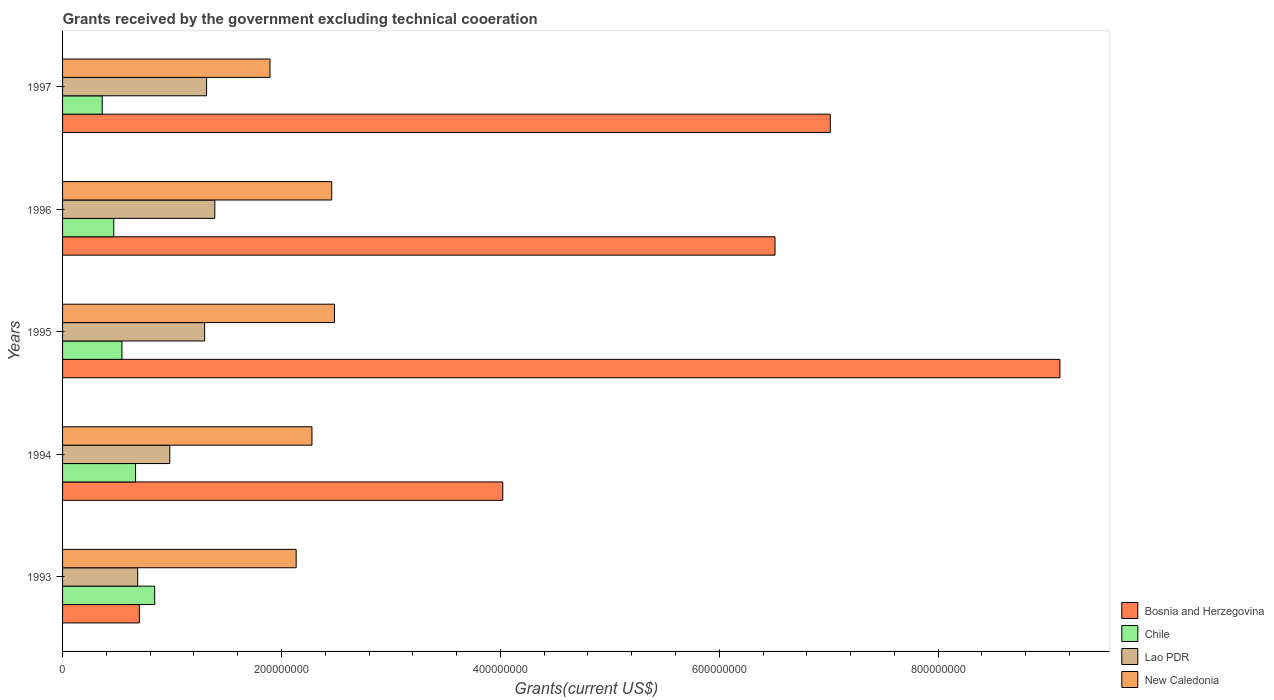How many different coloured bars are there?
Offer a very short reply. 4. Are the number of bars per tick equal to the number of legend labels?
Ensure brevity in your answer.  Yes. Are the number of bars on each tick of the Y-axis equal?
Give a very brief answer. Yes. How many bars are there on the 1st tick from the top?
Give a very brief answer. 4. How many bars are there on the 5th tick from the bottom?
Your answer should be compact. 4. In how many cases, is the number of bars for a given year not equal to the number of legend labels?
Give a very brief answer. 0. What is the total grants received by the government in New Caledonia in 1993?
Provide a short and direct response. 2.13e+08. Across all years, what is the maximum total grants received by the government in Chile?
Your answer should be compact. 8.42e+07. Across all years, what is the minimum total grants received by the government in Bosnia and Herzegovina?
Offer a very short reply. 7.02e+07. In which year was the total grants received by the government in Chile minimum?
Your answer should be compact. 1997. What is the total total grants received by the government in Bosnia and Herzegovina in the graph?
Ensure brevity in your answer.  2.74e+09. What is the difference between the total grants received by the government in Lao PDR in 1995 and that in 1996?
Your response must be concise. -9.30e+06. What is the difference between the total grants received by the government in New Caledonia in 1994 and the total grants received by the government in Chile in 1996?
Your answer should be compact. 1.81e+08. What is the average total grants received by the government in Chile per year?
Give a very brief answer. 5.76e+07. In the year 1996, what is the difference between the total grants received by the government in New Caledonia and total grants received by the government in Bosnia and Herzegovina?
Offer a very short reply. -4.05e+08. What is the ratio of the total grants received by the government in Lao PDR in 1994 to that in 1995?
Offer a terse response. 0.75. Is the total grants received by the government in New Caledonia in 1993 less than that in 1997?
Provide a succinct answer. No. Is the difference between the total grants received by the government in New Caledonia in 1996 and 1997 greater than the difference between the total grants received by the government in Bosnia and Herzegovina in 1996 and 1997?
Give a very brief answer. Yes. What is the difference between the highest and the second highest total grants received by the government in New Caledonia?
Make the answer very short. 2.51e+06. What is the difference between the highest and the lowest total grants received by the government in Chile?
Your response must be concise. 4.79e+07. In how many years, is the total grants received by the government in Lao PDR greater than the average total grants received by the government in Lao PDR taken over all years?
Offer a terse response. 3. Is it the case that in every year, the sum of the total grants received by the government in Lao PDR and total grants received by the government in New Caledonia is greater than the sum of total grants received by the government in Chile and total grants received by the government in Bosnia and Herzegovina?
Ensure brevity in your answer.  No. What does the 1st bar from the top in 1994 represents?
Offer a very short reply. New Caledonia. What does the 3rd bar from the bottom in 1994 represents?
Provide a succinct answer. Lao PDR. How many years are there in the graph?
Provide a short and direct response. 5. What is the difference between two consecutive major ticks on the X-axis?
Ensure brevity in your answer.  2.00e+08. Does the graph contain any zero values?
Provide a succinct answer. No. Where does the legend appear in the graph?
Ensure brevity in your answer.  Bottom right. How many legend labels are there?
Provide a short and direct response. 4. What is the title of the graph?
Keep it short and to the point. Grants received by the government excluding technical cooeration. Does "Cuba" appear as one of the legend labels in the graph?
Give a very brief answer. No. What is the label or title of the X-axis?
Provide a succinct answer. Grants(current US$). What is the Grants(current US$) of Bosnia and Herzegovina in 1993?
Offer a very short reply. 7.02e+07. What is the Grants(current US$) in Chile in 1993?
Ensure brevity in your answer.  8.42e+07. What is the Grants(current US$) in Lao PDR in 1993?
Your answer should be very brief. 6.86e+07. What is the Grants(current US$) in New Caledonia in 1993?
Keep it short and to the point. 2.13e+08. What is the Grants(current US$) in Bosnia and Herzegovina in 1994?
Offer a terse response. 4.02e+08. What is the Grants(current US$) in Chile in 1994?
Provide a short and direct response. 6.67e+07. What is the Grants(current US$) of Lao PDR in 1994?
Your response must be concise. 9.80e+07. What is the Grants(current US$) in New Caledonia in 1994?
Offer a terse response. 2.28e+08. What is the Grants(current US$) of Bosnia and Herzegovina in 1995?
Offer a terse response. 9.11e+08. What is the Grants(current US$) of Chile in 1995?
Your response must be concise. 5.42e+07. What is the Grants(current US$) of Lao PDR in 1995?
Give a very brief answer. 1.30e+08. What is the Grants(current US$) in New Caledonia in 1995?
Your response must be concise. 2.48e+08. What is the Grants(current US$) in Bosnia and Herzegovina in 1996?
Give a very brief answer. 6.51e+08. What is the Grants(current US$) in Chile in 1996?
Provide a succinct answer. 4.68e+07. What is the Grants(current US$) in Lao PDR in 1996?
Offer a terse response. 1.39e+08. What is the Grants(current US$) in New Caledonia in 1996?
Your response must be concise. 2.46e+08. What is the Grants(current US$) in Bosnia and Herzegovina in 1997?
Provide a succinct answer. 7.01e+08. What is the Grants(current US$) in Chile in 1997?
Your response must be concise. 3.62e+07. What is the Grants(current US$) in Lao PDR in 1997?
Ensure brevity in your answer.  1.32e+08. What is the Grants(current US$) in New Caledonia in 1997?
Offer a very short reply. 1.90e+08. Across all years, what is the maximum Grants(current US$) in Bosnia and Herzegovina?
Keep it short and to the point. 9.11e+08. Across all years, what is the maximum Grants(current US$) of Chile?
Give a very brief answer. 8.42e+07. Across all years, what is the maximum Grants(current US$) in Lao PDR?
Offer a terse response. 1.39e+08. Across all years, what is the maximum Grants(current US$) of New Caledonia?
Offer a terse response. 2.48e+08. Across all years, what is the minimum Grants(current US$) in Bosnia and Herzegovina?
Provide a short and direct response. 7.02e+07. Across all years, what is the minimum Grants(current US$) in Chile?
Provide a short and direct response. 3.62e+07. Across all years, what is the minimum Grants(current US$) in Lao PDR?
Offer a terse response. 6.86e+07. Across all years, what is the minimum Grants(current US$) in New Caledonia?
Your response must be concise. 1.90e+08. What is the total Grants(current US$) in Bosnia and Herzegovina in the graph?
Keep it short and to the point. 2.74e+09. What is the total Grants(current US$) of Chile in the graph?
Your answer should be compact. 2.88e+08. What is the total Grants(current US$) of Lao PDR in the graph?
Keep it short and to the point. 5.67e+08. What is the total Grants(current US$) in New Caledonia in the graph?
Give a very brief answer. 1.13e+09. What is the difference between the Grants(current US$) in Bosnia and Herzegovina in 1993 and that in 1994?
Ensure brevity in your answer.  -3.32e+08. What is the difference between the Grants(current US$) of Chile in 1993 and that in 1994?
Your response must be concise. 1.75e+07. What is the difference between the Grants(current US$) in Lao PDR in 1993 and that in 1994?
Provide a short and direct response. -2.93e+07. What is the difference between the Grants(current US$) of New Caledonia in 1993 and that in 1994?
Provide a succinct answer. -1.44e+07. What is the difference between the Grants(current US$) in Bosnia and Herzegovina in 1993 and that in 1995?
Provide a succinct answer. -8.41e+08. What is the difference between the Grants(current US$) in Chile in 1993 and that in 1995?
Your response must be concise. 2.99e+07. What is the difference between the Grants(current US$) of Lao PDR in 1993 and that in 1995?
Ensure brevity in your answer.  -6.12e+07. What is the difference between the Grants(current US$) in New Caledonia in 1993 and that in 1995?
Keep it short and to the point. -3.50e+07. What is the difference between the Grants(current US$) in Bosnia and Herzegovina in 1993 and that in 1996?
Make the answer very short. -5.81e+08. What is the difference between the Grants(current US$) of Chile in 1993 and that in 1996?
Keep it short and to the point. 3.74e+07. What is the difference between the Grants(current US$) in Lao PDR in 1993 and that in 1996?
Make the answer very short. -7.05e+07. What is the difference between the Grants(current US$) of New Caledonia in 1993 and that in 1996?
Provide a short and direct response. -3.25e+07. What is the difference between the Grants(current US$) of Bosnia and Herzegovina in 1993 and that in 1997?
Your answer should be compact. -6.31e+08. What is the difference between the Grants(current US$) of Chile in 1993 and that in 1997?
Provide a succinct answer. 4.79e+07. What is the difference between the Grants(current US$) of Lao PDR in 1993 and that in 1997?
Your response must be concise. -6.29e+07. What is the difference between the Grants(current US$) in New Caledonia in 1993 and that in 1997?
Offer a very short reply. 2.39e+07. What is the difference between the Grants(current US$) of Bosnia and Herzegovina in 1994 and that in 1995?
Your answer should be compact. -5.09e+08. What is the difference between the Grants(current US$) of Chile in 1994 and that in 1995?
Give a very brief answer. 1.24e+07. What is the difference between the Grants(current US$) in Lao PDR in 1994 and that in 1995?
Offer a terse response. -3.18e+07. What is the difference between the Grants(current US$) of New Caledonia in 1994 and that in 1995?
Provide a short and direct response. -2.06e+07. What is the difference between the Grants(current US$) in Bosnia and Herzegovina in 1994 and that in 1996?
Your answer should be compact. -2.49e+08. What is the difference between the Grants(current US$) in Chile in 1994 and that in 1996?
Ensure brevity in your answer.  1.99e+07. What is the difference between the Grants(current US$) in Lao PDR in 1994 and that in 1996?
Provide a succinct answer. -4.11e+07. What is the difference between the Grants(current US$) of New Caledonia in 1994 and that in 1996?
Make the answer very short. -1.80e+07. What is the difference between the Grants(current US$) in Bosnia and Herzegovina in 1994 and that in 1997?
Offer a very short reply. -2.99e+08. What is the difference between the Grants(current US$) in Chile in 1994 and that in 1997?
Provide a short and direct response. 3.04e+07. What is the difference between the Grants(current US$) of Lao PDR in 1994 and that in 1997?
Offer a very short reply. -3.36e+07. What is the difference between the Grants(current US$) in New Caledonia in 1994 and that in 1997?
Provide a short and direct response. 3.83e+07. What is the difference between the Grants(current US$) of Bosnia and Herzegovina in 1995 and that in 1996?
Keep it short and to the point. 2.60e+08. What is the difference between the Grants(current US$) in Chile in 1995 and that in 1996?
Provide a short and direct response. 7.46e+06. What is the difference between the Grants(current US$) of Lao PDR in 1995 and that in 1996?
Provide a short and direct response. -9.30e+06. What is the difference between the Grants(current US$) of New Caledonia in 1995 and that in 1996?
Your response must be concise. 2.51e+06. What is the difference between the Grants(current US$) in Bosnia and Herzegovina in 1995 and that in 1997?
Give a very brief answer. 2.10e+08. What is the difference between the Grants(current US$) in Chile in 1995 and that in 1997?
Ensure brevity in your answer.  1.80e+07. What is the difference between the Grants(current US$) in Lao PDR in 1995 and that in 1997?
Give a very brief answer. -1.77e+06. What is the difference between the Grants(current US$) in New Caledonia in 1995 and that in 1997?
Ensure brevity in your answer.  5.89e+07. What is the difference between the Grants(current US$) in Bosnia and Herzegovina in 1996 and that in 1997?
Give a very brief answer. -5.05e+07. What is the difference between the Grants(current US$) of Chile in 1996 and that in 1997?
Provide a short and direct response. 1.05e+07. What is the difference between the Grants(current US$) in Lao PDR in 1996 and that in 1997?
Provide a succinct answer. 7.53e+06. What is the difference between the Grants(current US$) in New Caledonia in 1996 and that in 1997?
Offer a very short reply. 5.64e+07. What is the difference between the Grants(current US$) in Bosnia and Herzegovina in 1993 and the Grants(current US$) in Chile in 1994?
Your response must be concise. 3.48e+06. What is the difference between the Grants(current US$) in Bosnia and Herzegovina in 1993 and the Grants(current US$) in Lao PDR in 1994?
Your answer should be compact. -2.78e+07. What is the difference between the Grants(current US$) in Bosnia and Herzegovina in 1993 and the Grants(current US$) in New Caledonia in 1994?
Your answer should be very brief. -1.58e+08. What is the difference between the Grants(current US$) in Chile in 1993 and the Grants(current US$) in Lao PDR in 1994?
Offer a terse response. -1.38e+07. What is the difference between the Grants(current US$) in Chile in 1993 and the Grants(current US$) in New Caledonia in 1994?
Your answer should be very brief. -1.44e+08. What is the difference between the Grants(current US$) in Lao PDR in 1993 and the Grants(current US$) in New Caledonia in 1994?
Ensure brevity in your answer.  -1.59e+08. What is the difference between the Grants(current US$) in Bosnia and Herzegovina in 1993 and the Grants(current US$) in Chile in 1995?
Provide a succinct answer. 1.59e+07. What is the difference between the Grants(current US$) in Bosnia and Herzegovina in 1993 and the Grants(current US$) in Lao PDR in 1995?
Give a very brief answer. -5.96e+07. What is the difference between the Grants(current US$) of Bosnia and Herzegovina in 1993 and the Grants(current US$) of New Caledonia in 1995?
Your answer should be very brief. -1.78e+08. What is the difference between the Grants(current US$) of Chile in 1993 and the Grants(current US$) of Lao PDR in 1995?
Keep it short and to the point. -4.56e+07. What is the difference between the Grants(current US$) of Chile in 1993 and the Grants(current US$) of New Caledonia in 1995?
Offer a very short reply. -1.64e+08. What is the difference between the Grants(current US$) of Lao PDR in 1993 and the Grants(current US$) of New Caledonia in 1995?
Provide a succinct answer. -1.80e+08. What is the difference between the Grants(current US$) of Bosnia and Herzegovina in 1993 and the Grants(current US$) of Chile in 1996?
Ensure brevity in your answer.  2.34e+07. What is the difference between the Grants(current US$) in Bosnia and Herzegovina in 1993 and the Grants(current US$) in Lao PDR in 1996?
Your answer should be very brief. -6.89e+07. What is the difference between the Grants(current US$) in Bosnia and Herzegovina in 1993 and the Grants(current US$) in New Caledonia in 1996?
Provide a short and direct response. -1.76e+08. What is the difference between the Grants(current US$) in Chile in 1993 and the Grants(current US$) in Lao PDR in 1996?
Offer a terse response. -5.49e+07. What is the difference between the Grants(current US$) in Chile in 1993 and the Grants(current US$) in New Caledonia in 1996?
Your answer should be very brief. -1.62e+08. What is the difference between the Grants(current US$) in Lao PDR in 1993 and the Grants(current US$) in New Caledonia in 1996?
Your answer should be very brief. -1.77e+08. What is the difference between the Grants(current US$) of Bosnia and Herzegovina in 1993 and the Grants(current US$) of Chile in 1997?
Give a very brief answer. 3.39e+07. What is the difference between the Grants(current US$) in Bosnia and Herzegovina in 1993 and the Grants(current US$) in Lao PDR in 1997?
Your response must be concise. -6.14e+07. What is the difference between the Grants(current US$) in Bosnia and Herzegovina in 1993 and the Grants(current US$) in New Caledonia in 1997?
Ensure brevity in your answer.  -1.19e+08. What is the difference between the Grants(current US$) in Chile in 1993 and the Grants(current US$) in Lao PDR in 1997?
Offer a very short reply. -4.74e+07. What is the difference between the Grants(current US$) in Chile in 1993 and the Grants(current US$) in New Caledonia in 1997?
Give a very brief answer. -1.05e+08. What is the difference between the Grants(current US$) in Lao PDR in 1993 and the Grants(current US$) in New Caledonia in 1997?
Give a very brief answer. -1.21e+08. What is the difference between the Grants(current US$) of Bosnia and Herzegovina in 1994 and the Grants(current US$) of Chile in 1995?
Offer a terse response. 3.48e+08. What is the difference between the Grants(current US$) in Bosnia and Herzegovina in 1994 and the Grants(current US$) in Lao PDR in 1995?
Offer a terse response. 2.72e+08. What is the difference between the Grants(current US$) of Bosnia and Herzegovina in 1994 and the Grants(current US$) of New Caledonia in 1995?
Ensure brevity in your answer.  1.54e+08. What is the difference between the Grants(current US$) in Chile in 1994 and the Grants(current US$) in Lao PDR in 1995?
Ensure brevity in your answer.  -6.31e+07. What is the difference between the Grants(current US$) in Chile in 1994 and the Grants(current US$) in New Caledonia in 1995?
Ensure brevity in your answer.  -1.82e+08. What is the difference between the Grants(current US$) in Lao PDR in 1994 and the Grants(current US$) in New Caledonia in 1995?
Your response must be concise. -1.50e+08. What is the difference between the Grants(current US$) of Bosnia and Herzegovina in 1994 and the Grants(current US$) of Chile in 1996?
Provide a short and direct response. 3.55e+08. What is the difference between the Grants(current US$) of Bosnia and Herzegovina in 1994 and the Grants(current US$) of Lao PDR in 1996?
Make the answer very short. 2.63e+08. What is the difference between the Grants(current US$) of Bosnia and Herzegovina in 1994 and the Grants(current US$) of New Caledonia in 1996?
Offer a very short reply. 1.56e+08. What is the difference between the Grants(current US$) of Chile in 1994 and the Grants(current US$) of Lao PDR in 1996?
Provide a succinct answer. -7.24e+07. What is the difference between the Grants(current US$) in Chile in 1994 and the Grants(current US$) in New Caledonia in 1996?
Ensure brevity in your answer.  -1.79e+08. What is the difference between the Grants(current US$) of Lao PDR in 1994 and the Grants(current US$) of New Caledonia in 1996?
Your answer should be compact. -1.48e+08. What is the difference between the Grants(current US$) of Bosnia and Herzegovina in 1994 and the Grants(current US$) of Chile in 1997?
Your answer should be compact. 3.66e+08. What is the difference between the Grants(current US$) of Bosnia and Herzegovina in 1994 and the Grants(current US$) of Lao PDR in 1997?
Your response must be concise. 2.71e+08. What is the difference between the Grants(current US$) in Bosnia and Herzegovina in 1994 and the Grants(current US$) in New Caledonia in 1997?
Your answer should be compact. 2.13e+08. What is the difference between the Grants(current US$) in Chile in 1994 and the Grants(current US$) in Lao PDR in 1997?
Give a very brief answer. -6.49e+07. What is the difference between the Grants(current US$) of Chile in 1994 and the Grants(current US$) of New Caledonia in 1997?
Make the answer very short. -1.23e+08. What is the difference between the Grants(current US$) in Lao PDR in 1994 and the Grants(current US$) in New Caledonia in 1997?
Keep it short and to the point. -9.16e+07. What is the difference between the Grants(current US$) of Bosnia and Herzegovina in 1995 and the Grants(current US$) of Chile in 1996?
Your response must be concise. 8.64e+08. What is the difference between the Grants(current US$) in Bosnia and Herzegovina in 1995 and the Grants(current US$) in Lao PDR in 1996?
Provide a short and direct response. 7.72e+08. What is the difference between the Grants(current US$) of Bosnia and Herzegovina in 1995 and the Grants(current US$) of New Caledonia in 1996?
Make the answer very short. 6.65e+08. What is the difference between the Grants(current US$) in Chile in 1995 and the Grants(current US$) in Lao PDR in 1996?
Your answer should be compact. -8.49e+07. What is the difference between the Grants(current US$) of Chile in 1995 and the Grants(current US$) of New Caledonia in 1996?
Your answer should be compact. -1.92e+08. What is the difference between the Grants(current US$) of Lao PDR in 1995 and the Grants(current US$) of New Caledonia in 1996?
Your response must be concise. -1.16e+08. What is the difference between the Grants(current US$) in Bosnia and Herzegovina in 1995 and the Grants(current US$) in Chile in 1997?
Provide a succinct answer. 8.75e+08. What is the difference between the Grants(current US$) in Bosnia and Herzegovina in 1995 and the Grants(current US$) in Lao PDR in 1997?
Provide a short and direct response. 7.80e+08. What is the difference between the Grants(current US$) of Bosnia and Herzegovina in 1995 and the Grants(current US$) of New Caledonia in 1997?
Offer a very short reply. 7.22e+08. What is the difference between the Grants(current US$) in Chile in 1995 and the Grants(current US$) in Lao PDR in 1997?
Ensure brevity in your answer.  -7.73e+07. What is the difference between the Grants(current US$) of Chile in 1995 and the Grants(current US$) of New Caledonia in 1997?
Ensure brevity in your answer.  -1.35e+08. What is the difference between the Grants(current US$) in Lao PDR in 1995 and the Grants(current US$) in New Caledonia in 1997?
Provide a short and direct response. -5.97e+07. What is the difference between the Grants(current US$) of Bosnia and Herzegovina in 1996 and the Grants(current US$) of Chile in 1997?
Offer a terse response. 6.15e+08. What is the difference between the Grants(current US$) in Bosnia and Herzegovina in 1996 and the Grants(current US$) in Lao PDR in 1997?
Offer a very short reply. 5.19e+08. What is the difference between the Grants(current US$) in Bosnia and Herzegovina in 1996 and the Grants(current US$) in New Caledonia in 1997?
Keep it short and to the point. 4.61e+08. What is the difference between the Grants(current US$) in Chile in 1996 and the Grants(current US$) in Lao PDR in 1997?
Ensure brevity in your answer.  -8.48e+07. What is the difference between the Grants(current US$) in Chile in 1996 and the Grants(current US$) in New Caledonia in 1997?
Provide a short and direct response. -1.43e+08. What is the difference between the Grants(current US$) in Lao PDR in 1996 and the Grants(current US$) in New Caledonia in 1997?
Offer a very short reply. -5.04e+07. What is the average Grants(current US$) in Bosnia and Herzegovina per year?
Offer a very short reply. 5.47e+08. What is the average Grants(current US$) of Chile per year?
Keep it short and to the point. 5.76e+07. What is the average Grants(current US$) of Lao PDR per year?
Offer a terse response. 1.13e+08. What is the average Grants(current US$) in New Caledonia per year?
Give a very brief answer. 2.25e+08. In the year 1993, what is the difference between the Grants(current US$) of Bosnia and Herzegovina and Grants(current US$) of Chile?
Your answer should be compact. -1.40e+07. In the year 1993, what is the difference between the Grants(current US$) in Bosnia and Herzegovina and Grants(current US$) in Lao PDR?
Make the answer very short. 1.52e+06. In the year 1993, what is the difference between the Grants(current US$) in Bosnia and Herzegovina and Grants(current US$) in New Caledonia?
Ensure brevity in your answer.  -1.43e+08. In the year 1993, what is the difference between the Grants(current US$) in Chile and Grants(current US$) in Lao PDR?
Keep it short and to the point. 1.55e+07. In the year 1993, what is the difference between the Grants(current US$) of Chile and Grants(current US$) of New Caledonia?
Your answer should be very brief. -1.29e+08. In the year 1993, what is the difference between the Grants(current US$) in Lao PDR and Grants(current US$) in New Caledonia?
Offer a terse response. -1.45e+08. In the year 1994, what is the difference between the Grants(current US$) in Bosnia and Herzegovina and Grants(current US$) in Chile?
Offer a terse response. 3.36e+08. In the year 1994, what is the difference between the Grants(current US$) in Bosnia and Herzegovina and Grants(current US$) in Lao PDR?
Ensure brevity in your answer.  3.04e+08. In the year 1994, what is the difference between the Grants(current US$) of Bosnia and Herzegovina and Grants(current US$) of New Caledonia?
Keep it short and to the point. 1.74e+08. In the year 1994, what is the difference between the Grants(current US$) in Chile and Grants(current US$) in Lao PDR?
Provide a succinct answer. -3.13e+07. In the year 1994, what is the difference between the Grants(current US$) in Chile and Grants(current US$) in New Caledonia?
Ensure brevity in your answer.  -1.61e+08. In the year 1994, what is the difference between the Grants(current US$) of Lao PDR and Grants(current US$) of New Caledonia?
Offer a very short reply. -1.30e+08. In the year 1995, what is the difference between the Grants(current US$) of Bosnia and Herzegovina and Grants(current US$) of Chile?
Provide a succinct answer. 8.57e+08. In the year 1995, what is the difference between the Grants(current US$) in Bosnia and Herzegovina and Grants(current US$) in Lao PDR?
Give a very brief answer. 7.81e+08. In the year 1995, what is the difference between the Grants(current US$) of Bosnia and Herzegovina and Grants(current US$) of New Caledonia?
Your answer should be very brief. 6.63e+08. In the year 1995, what is the difference between the Grants(current US$) in Chile and Grants(current US$) in Lao PDR?
Your response must be concise. -7.56e+07. In the year 1995, what is the difference between the Grants(current US$) in Chile and Grants(current US$) in New Caledonia?
Offer a terse response. -1.94e+08. In the year 1995, what is the difference between the Grants(current US$) in Lao PDR and Grants(current US$) in New Caledonia?
Offer a terse response. -1.19e+08. In the year 1996, what is the difference between the Grants(current US$) of Bosnia and Herzegovina and Grants(current US$) of Chile?
Provide a short and direct response. 6.04e+08. In the year 1996, what is the difference between the Grants(current US$) in Bosnia and Herzegovina and Grants(current US$) in Lao PDR?
Your answer should be compact. 5.12e+08. In the year 1996, what is the difference between the Grants(current US$) of Bosnia and Herzegovina and Grants(current US$) of New Caledonia?
Offer a terse response. 4.05e+08. In the year 1996, what is the difference between the Grants(current US$) in Chile and Grants(current US$) in Lao PDR?
Your response must be concise. -9.23e+07. In the year 1996, what is the difference between the Grants(current US$) in Chile and Grants(current US$) in New Caledonia?
Offer a terse response. -1.99e+08. In the year 1996, what is the difference between the Grants(current US$) of Lao PDR and Grants(current US$) of New Caledonia?
Your answer should be very brief. -1.07e+08. In the year 1997, what is the difference between the Grants(current US$) of Bosnia and Herzegovina and Grants(current US$) of Chile?
Give a very brief answer. 6.65e+08. In the year 1997, what is the difference between the Grants(current US$) of Bosnia and Herzegovina and Grants(current US$) of Lao PDR?
Give a very brief answer. 5.70e+08. In the year 1997, what is the difference between the Grants(current US$) in Bosnia and Herzegovina and Grants(current US$) in New Caledonia?
Your answer should be compact. 5.12e+08. In the year 1997, what is the difference between the Grants(current US$) of Chile and Grants(current US$) of Lao PDR?
Offer a very short reply. -9.53e+07. In the year 1997, what is the difference between the Grants(current US$) of Chile and Grants(current US$) of New Caledonia?
Make the answer very short. -1.53e+08. In the year 1997, what is the difference between the Grants(current US$) of Lao PDR and Grants(current US$) of New Caledonia?
Keep it short and to the point. -5.80e+07. What is the ratio of the Grants(current US$) in Bosnia and Herzegovina in 1993 to that in 1994?
Ensure brevity in your answer.  0.17. What is the ratio of the Grants(current US$) in Chile in 1993 to that in 1994?
Your answer should be very brief. 1.26. What is the ratio of the Grants(current US$) of Lao PDR in 1993 to that in 1994?
Provide a short and direct response. 0.7. What is the ratio of the Grants(current US$) of New Caledonia in 1993 to that in 1994?
Give a very brief answer. 0.94. What is the ratio of the Grants(current US$) in Bosnia and Herzegovina in 1993 to that in 1995?
Your answer should be very brief. 0.08. What is the ratio of the Grants(current US$) of Chile in 1993 to that in 1995?
Offer a very short reply. 1.55. What is the ratio of the Grants(current US$) in Lao PDR in 1993 to that in 1995?
Your answer should be compact. 0.53. What is the ratio of the Grants(current US$) of New Caledonia in 1993 to that in 1995?
Keep it short and to the point. 0.86. What is the ratio of the Grants(current US$) in Bosnia and Herzegovina in 1993 to that in 1996?
Ensure brevity in your answer.  0.11. What is the ratio of the Grants(current US$) of Chile in 1993 to that in 1996?
Provide a short and direct response. 1.8. What is the ratio of the Grants(current US$) in Lao PDR in 1993 to that in 1996?
Keep it short and to the point. 0.49. What is the ratio of the Grants(current US$) of New Caledonia in 1993 to that in 1996?
Your response must be concise. 0.87. What is the ratio of the Grants(current US$) in Chile in 1993 to that in 1997?
Your response must be concise. 2.32. What is the ratio of the Grants(current US$) in Lao PDR in 1993 to that in 1997?
Provide a succinct answer. 0.52. What is the ratio of the Grants(current US$) of New Caledonia in 1993 to that in 1997?
Give a very brief answer. 1.13. What is the ratio of the Grants(current US$) of Bosnia and Herzegovina in 1994 to that in 1995?
Provide a succinct answer. 0.44. What is the ratio of the Grants(current US$) of Chile in 1994 to that in 1995?
Your answer should be very brief. 1.23. What is the ratio of the Grants(current US$) in Lao PDR in 1994 to that in 1995?
Offer a very short reply. 0.75. What is the ratio of the Grants(current US$) of New Caledonia in 1994 to that in 1995?
Ensure brevity in your answer.  0.92. What is the ratio of the Grants(current US$) of Bosnia and Herzegovina in 1994 to that in 1996?
Your response must be concise. 0.62. What is the ratio of the Grants(current US$) in Chile in 1994 to that in 1996?
Your answer should be compact. 1.43. What is the ratio of the Grants(current US$) in Lao PDR in 1994 to that in 1996?
Offer a terse response. 0.7. What is the ratio of the Grants(current US$) of New Caledonia in 1994 to that in 1996?
Your answer should be very brief. 0.93. What is the ratio of the Grants(current US$) of Bosnia and Herzegovina in 1994 to that in 1997?
Keep it short and to the point. 0.57. What is the ratio of the Grants(current US$) in Chile in 1994 to that in 1997?
Ensure brevity in your answer.  1.84. What is the ratio of the Grants(current US$) in Lao PDR in 1994 to that in 1997?
Your answer should be compact. 0.74. What is the ratio of the Grants(current US$) in New Caledonia in 1994 to that in 1997?
Provide a succinct answer. 1.2. What is the ratio of the Grants(current US$) of Bosnia and Herzegovina in 1995 to that in 1996?
Your answer should be compact. 1.4. What is the ratio of the Grants(current US$) in Chile in 1995 to that in 1996?
Your response must be concise. 1.16. What is the ratio of the Grants(current US$) of Lao PDR in 1995 to that in 1996?
Make the answer very short. 0.93. What is the ratio of the Grants(current US$) in New Caledonia in 1995 to that in 1996?
Make the answer very short. 1.01. What is the ratio of the Grants(current US$) of Bosnia and Herzegovina in 1995 to that in 1997?
Make the answer very short. 1.3. What is the ratio of the Grants(current US$) of Chile in 1995 to that in 1997?
Offer a very short reply. 1.5. What is the ratio of the Grants(current US$) of Lao PDR in 1995 to that in 1997?
Provide a succinct answer. 0.99. What is the ratio of the Grants(current US$) of New Caledonia in 1995 to that in 1997?
Your answer should be very brief. 1.31. What is the ratio of the Grants(current US$) of Bosnia and Herzegovina in 1996 to that in 1997?
Give a very brief answer. 0.93. What is the ratio of the Grants(current US$) in Chile in 1996 to that in 1997?
Give a very brief answer. 1.29. What is the ratio of the Grants(current US$) of Lao PDR in 1996 to that in 1997?
Keep it short and to the point. 1.06. What is the ratio of the Grants(current US$) in New Caledonia in 1996 to that in 1997?
Your answer should be compact. 1.3. What is the difference between the highest and the second highest Grants(current US$) in Bosnia and Herzegovina?
Offer a very short reply. 2.10e+08. What is the difference between the highest and the second highest Grants(current US$) of Chile?
Offer a terse response. 1.75e+07. What is the difference between the highest and the second highest Grants(current US$) of Lao PDR?
Your answer should be very brief. 7.53e+06. What is the difference between the highest and the second highest Grants(current US$) in New Caledonia?
Your answer should be compact. 2.51e+06. What is the difference between the highest and the lowest Grants(current US$) of Bosnia and Herzegovina?
Ensure brevity in your answer.  8.41e+08. What is the difference between the highest and the lowest Grants(current US$) in Chile?
Offer a terse response. 4.79e+07. What is the difference between the highest and the lowest Grants(current US$) in Lao PDR?
Provide a short and direct response. 7.05e+07. What is the difference between the highest and the lowest Grants(current US$) in New Caledonia?
Your response must be concise. 5.89e+07. 